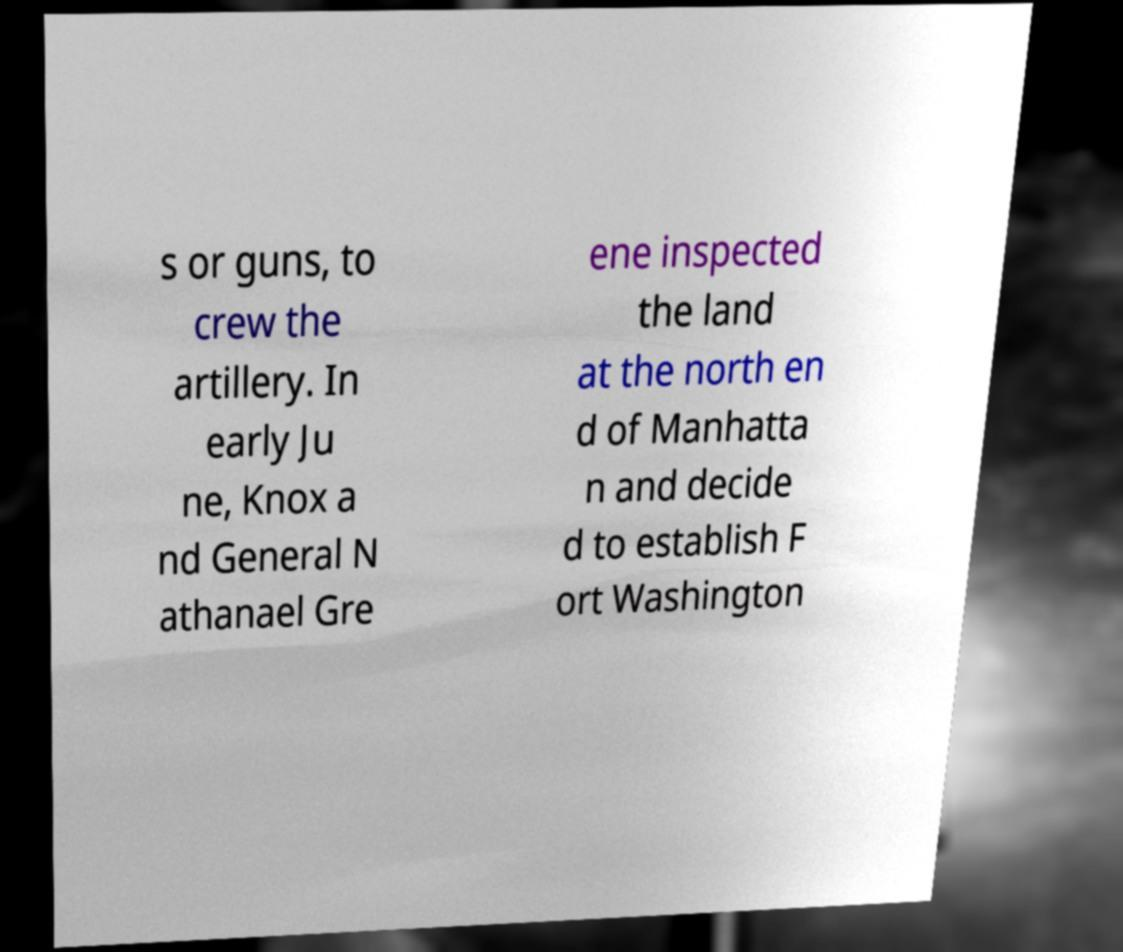Please read and relay the text visible in this image. What does it say? s or guns, to crew the artillery. In early Ju ne, Knox a nd General N athanael Gre ene inspected the land at the north en d of Manhatta n and decide d to establish F ort Washington 